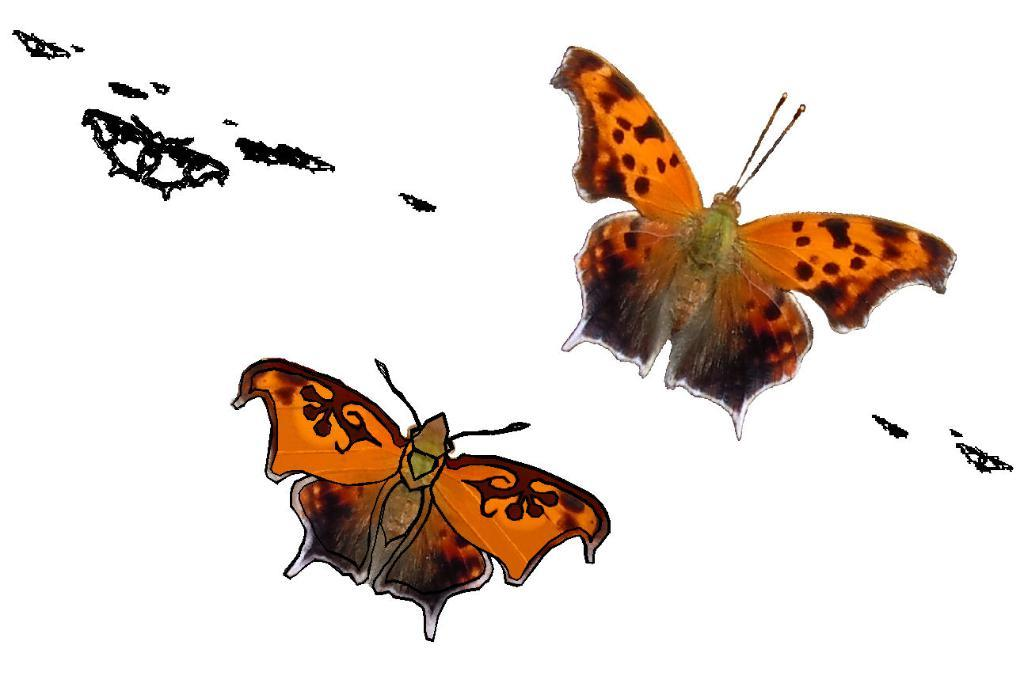What type of artwork is depicted in the image? There are butterfly paintings in the image. What type of sugar is used in the butterfly paintings? There is no sugar mentioned or depicted in the butterfly paintings; they are simply paintings of butterflies. 